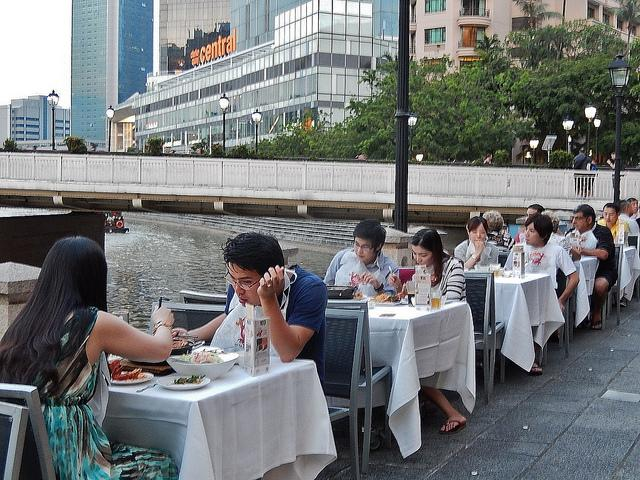What kind of meal are they having? Please explain your reasoning. lobster. There are people wearing plastic bibs over there shirts which is associated with eating lobster as it is a food that is messy and sprays. there is also a red food on the nearest plates that looks like a lobster. 